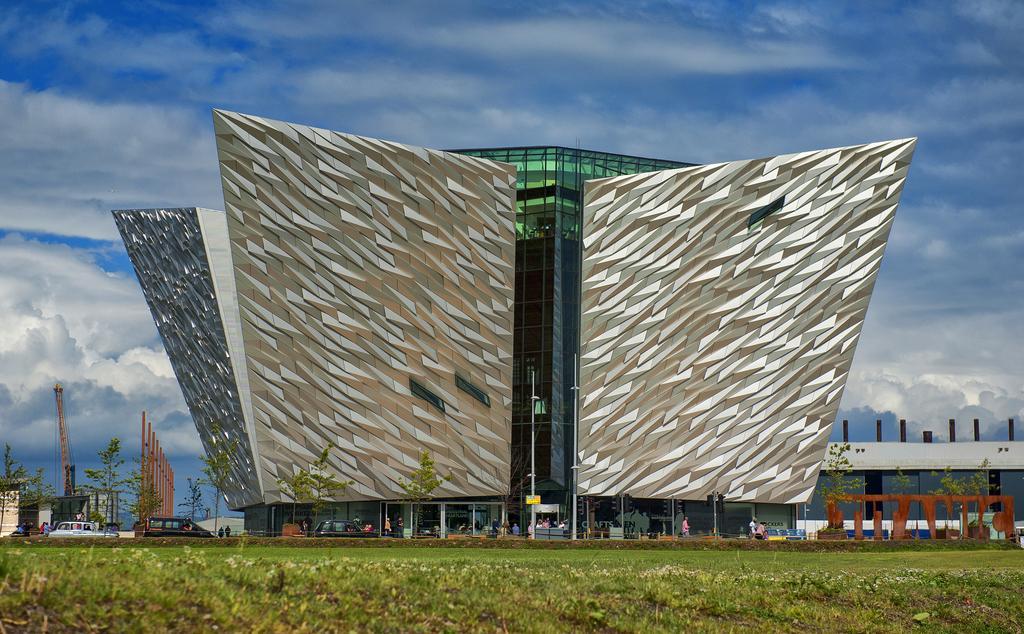Describe this image in one or two sentences. In the center of the image there is building and poles. At the bottom of the image we can see cars, persons, trees, grass and doors. In the background we can see tower, building, sky and clouds. 